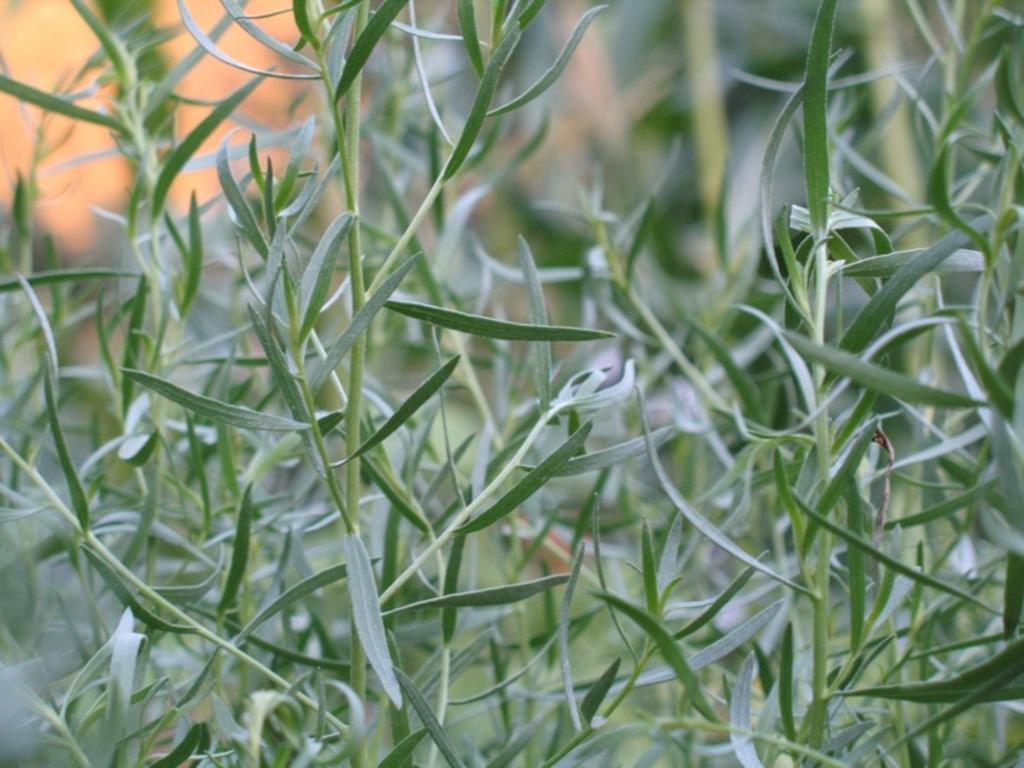Please provide a concise description of this image. In this image we can see some plants, and the background is blurred. 